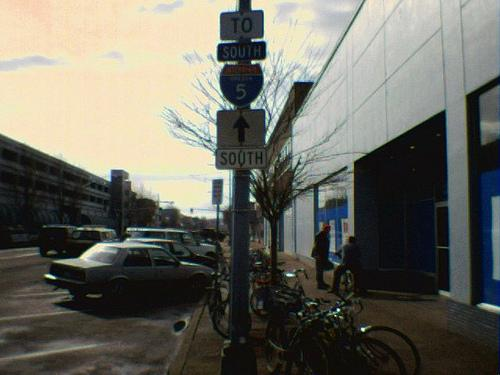Why are the bikes on the poles? locked up 